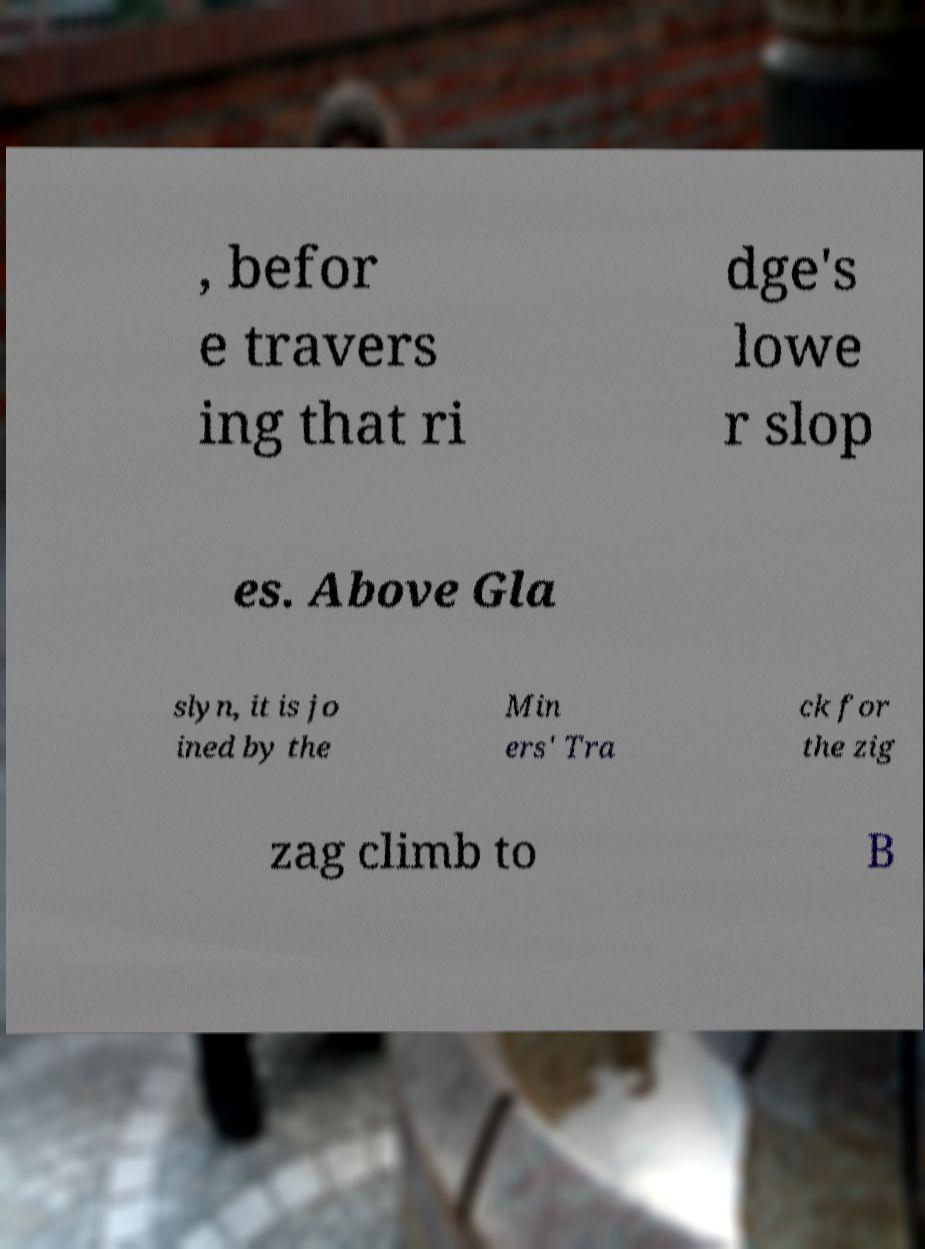Can you accurately transcribe the text from the provided image for me? , befor e travers ing that ri dge's lowe r slop es. Above Gla slyn, it is jo ined by the Min ers' Tra ck for the zig zag climb to B 